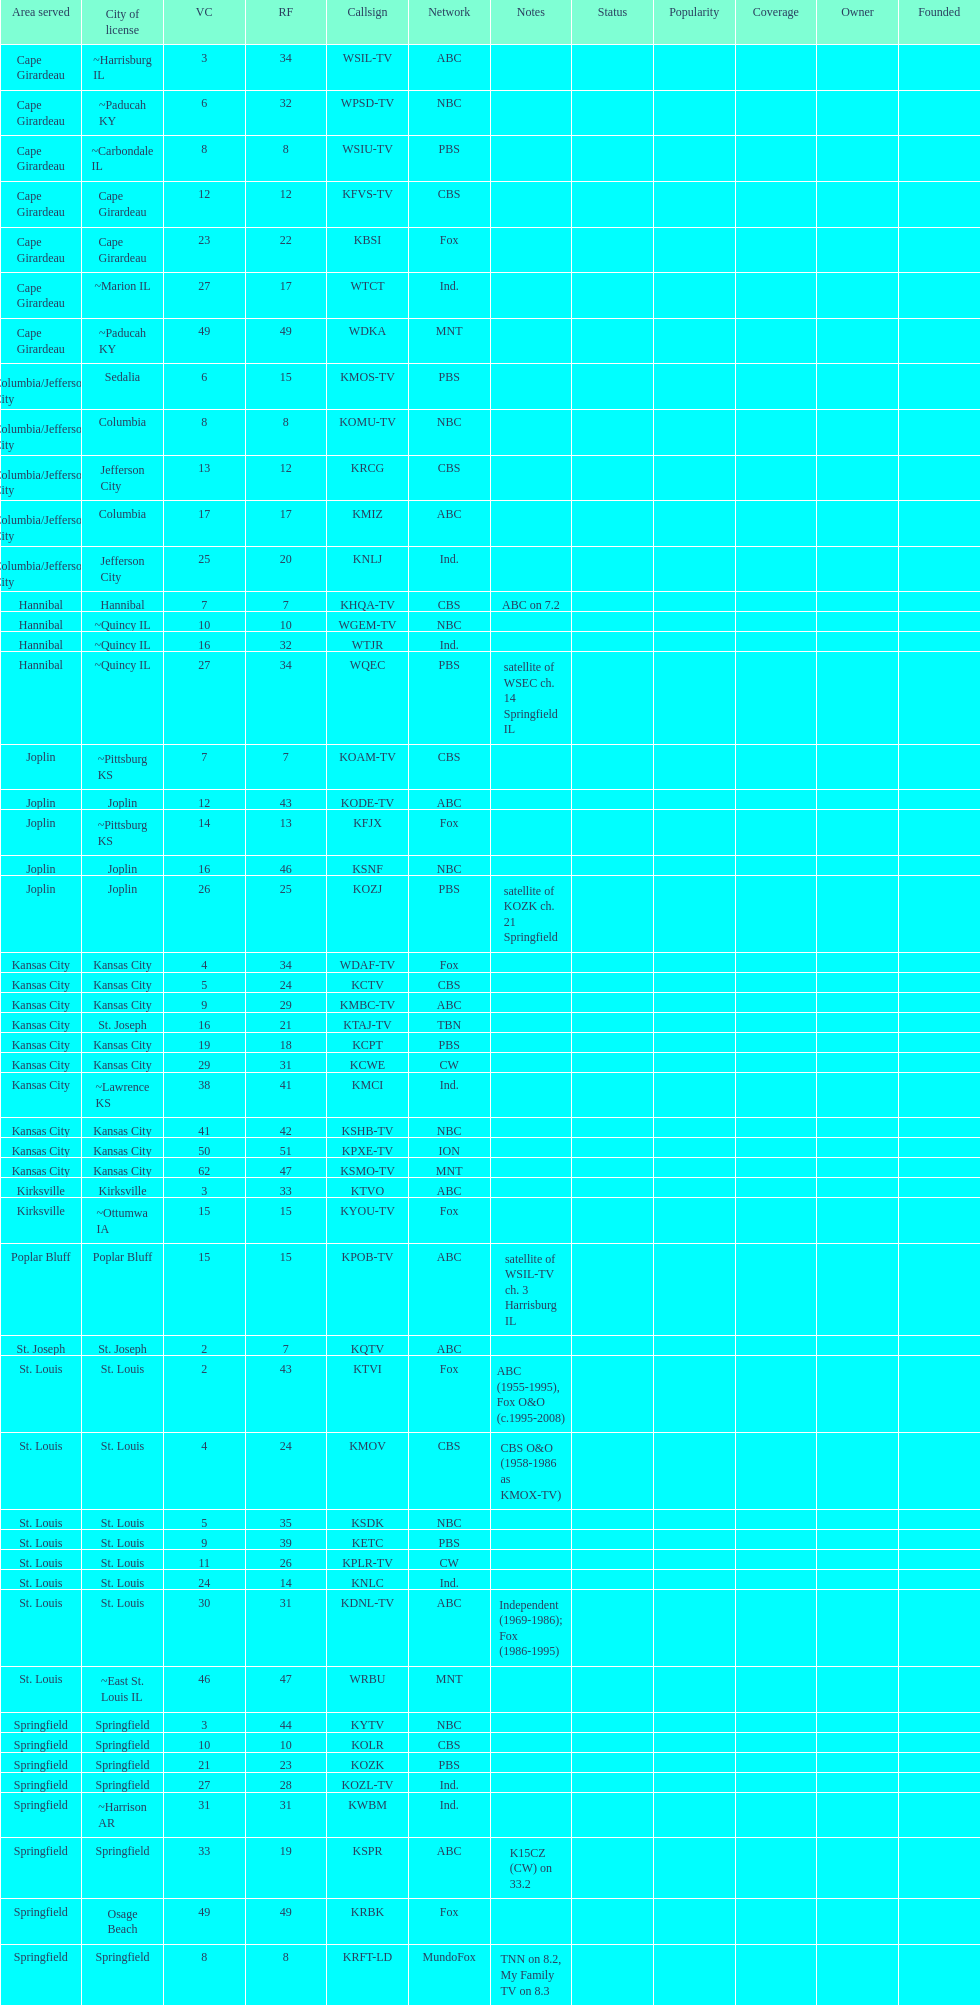What is the total number of stations serving the the cape girardeau area? 7. 